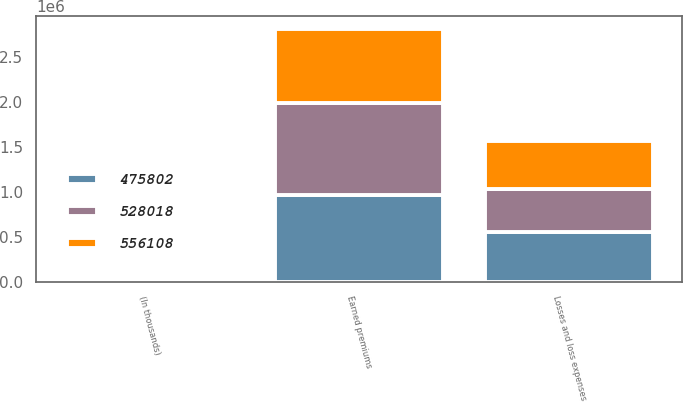<chart> <loc_0><loc_0><loc_500><loc_500><stacked_bar_chart><ecel><fcel>(In thousands)<fcel>Earned premiums<fcel>Losses and loss expenses<nl><fcel>528018<fcel>2014<fcel>1.03067e+06<fcel>475802<nl><fcel>475802<fcel>2013<fcel>959537<fcel>556108<nl><fcel>556108<fcel>2012<fcel>821347<fcel>528018<nl></chart> 